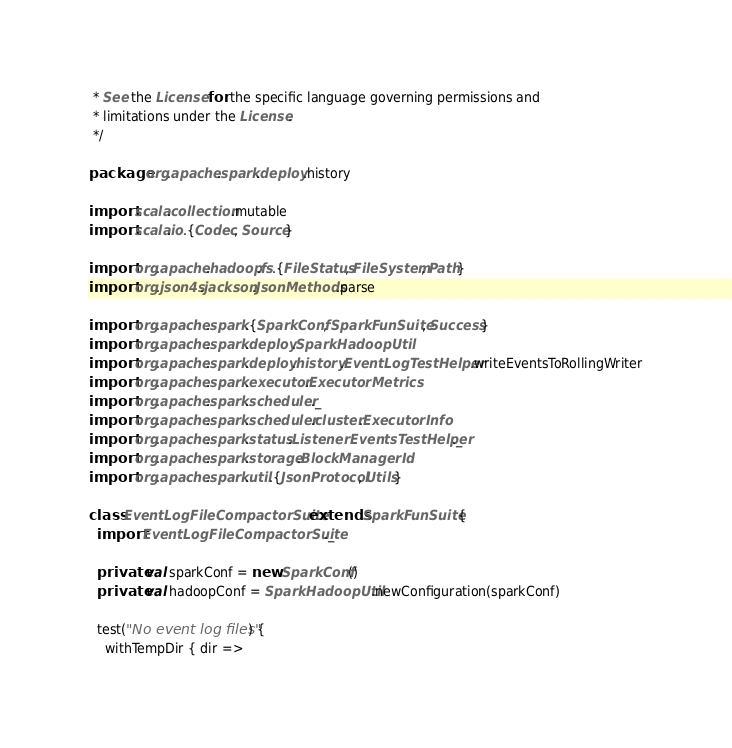Convert code to text. <code><loc_0><loc_0><loc_500><loc_500><_Scala_> * See the License for the specific language governing permissions and
 * limitations under the License.
 */

package org.apache.spark.deploy.history

import scala.collection.mutable
import scala.io.{Codec, Source}

import org.apache.hadoop.fs.{FileStatus, FileSystem, Path}
import org.json4s.jackson.JsonMethods.parse

import org.apache.spark.{SparkConf, SparkFunSuite, Success}
import org.apache.spark.deploy.SparkHadoopUtil
import org.apache.spark.deploy.history.EventLogTestHelper.writeEventsToRollingWriter
import org.apache.spark.executor.ExecutorMetrics
import org.apache.spark.scheduler._
import org.apache.spark.scheduler.cluster.ExecutorInfo
import org.apache.spark.status.ListenerEventsTestHelper._
import org.apache.spark.storage.BlockManagerId
import org.apache.spark.util.{JsonProtocol, Utils}

class EventLogFileCompactorSuite extends SparkFunSuite {
  import EventLogFileCompactorSuite._

  private val sparkConf = new SparkConf()
  private val hadoopConf = SparkHadoopUtil.newConfiguration(sparkConf)

  test("No event log files") {
    withTempDir { dir =></code> 